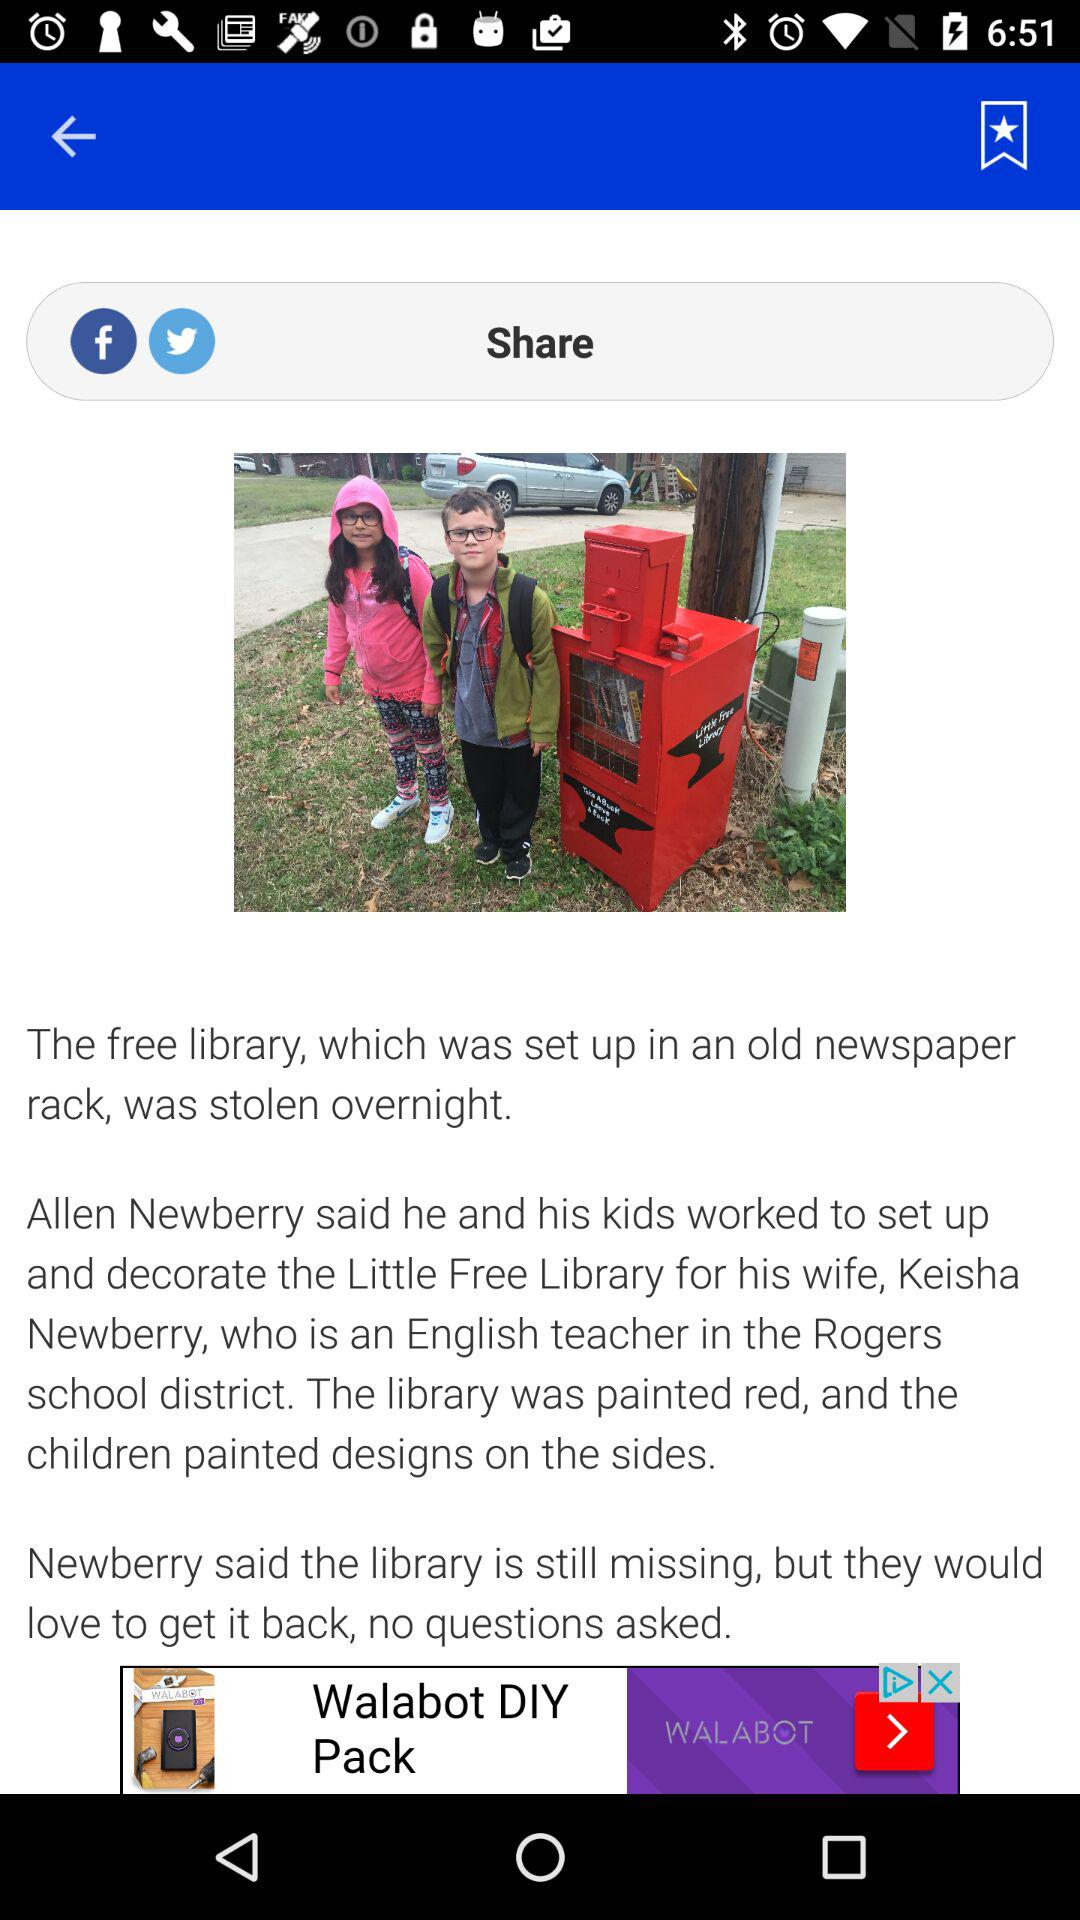Who wrote the article?
When the provided information is insufficient, respond with <no answer>. <no answer> 